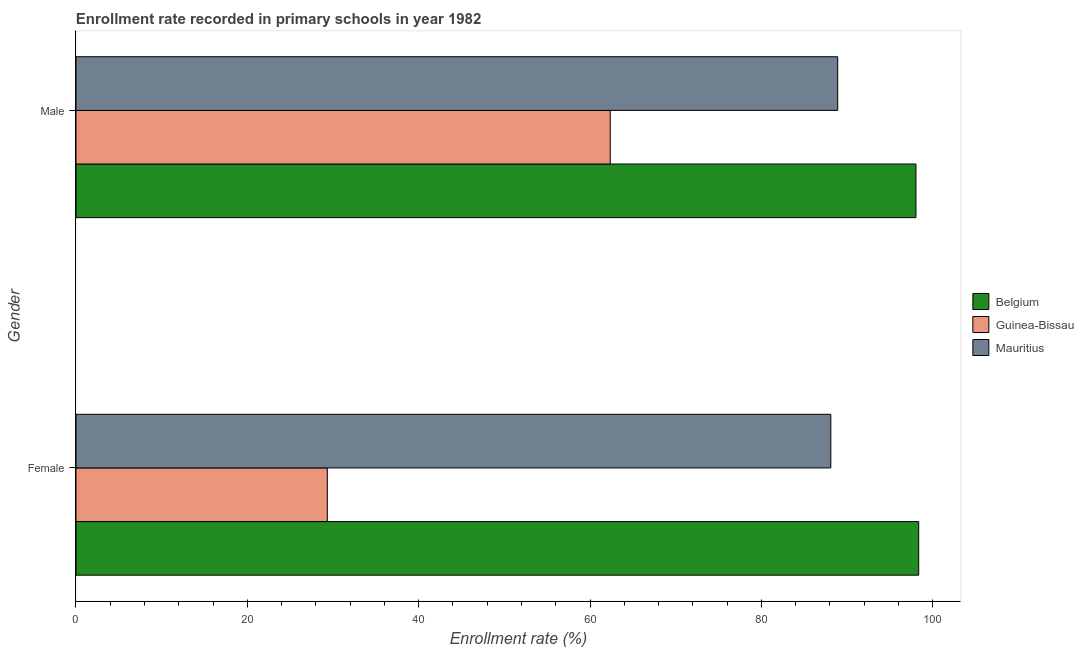Are the number of bars on each tick of the Y-axis equal?
Ensure brevity in your answer.  Yes. What is the label of the 2nd group of bars from the top?
Offer a very short reply. Female. What is the enrollment rate of male students in Belgium?
Your answer should be very brief. 98.04. Across all countries, what is the maximum enrollment rate of female students?
Offer a very short reply. 98.37. Across all countries, what is the minimum enrollment rate of female students?
Offer a terse response. 29.34. In which country was the enrollment rate of male students minimum?
Your answer should be very brief. Guinea-Bissau. What is the total enrollment rate of female students in the graph?
Provide a succinct answer. 215.81. What is the difference between the enrollment rate of male students in Guinea-Bissau and that in Mauritius?
Provide a succinct answer. -26.55. What is the difference between the enrollment rate of male students in Belgium and the enrollment rate of female students in Guinea-Bissau?
Keep it short and to the point. 68.71. What is the average enrollment rate of male students per country?
Ensure brevity in your answer.  83.1. What is the difference between the enrollment rate of female students and enrollment rate of male students in Mauritius?
Offer a very short reply. -0.8. In how many countries, is the enrollment rate of male students greater than 88 %?
Offer a terse response. 2. What is the ratio of the enrollment rate of female students in Belgium to that in Guinea-Bissau?
Offer a terse response. 3.35. Is the enrollment rate of female students in Mauritius less than that in Belgium?
Ensure brevity in your answer.  Yes. What does the 1st bar from the top in Male represents?
Your response must be concise. Mauritius. What does the 3rd bar from the bottom in Male represents?
Provide a succinct answer. Mauritius. Are the values on the major ticks of X-axis written in scientific E-notation?
Your answer should be very brief. No. Does the graph contain grids?
Make the answer very short. No. How many legend labels are there?
Your answer should be very brief. 3. What is the title of the graph?
Provide a succinct answer. Enrollment rate recorded in primary schools in year 1982. What is the label or title of the X-axis?
Offer a terse response. Enrollment rate (%). What is the Enrollment rate (%) in Belgium in Female?
Ensure brevity in your answer.  98.37. What is the Enrollment rate (%) of Guinea-Bissau in Female?
Ensure brevity in your answer.  29.34. What is the Enrollment rate (%) of Mauritius in Female?
Provide a short and direct response. 88.11. What is the Enrollment rate (%) of Belgium in Male?
Offer a very short reply. 98.04. What is the Enrollment rate (%) in Guinea-Bissau in Male?
Provide a short and direct response. 62.36. What is the Enrollment rate (%) of Mauritius in Male?
Your response must be concise. 88.91. Across all Gender, what is the maximum Enrollment rate (%) in Belgium?
Provide a short and direct response. 98.37. Across all Gender, what is the maximum Enrollment rate (%) in Guinea-Bissau?
Give a very brief answer. 62.36. Across all Gender, what is the maximum Enrollment rate (%) of Mauritius?
Provide a short and direct response. 88.91. Across all Gender, what is the minimum Enrollment rate (%) of Belgium?
Provide a short and direct response. 98.04. Across all Gender, what is the minimum Enrollment rate (%) of Guinea-Bissau?
Give a very brief answer. 29.34. Across all Gender, what is the minimum Enrollment rate (%) in Mauritius?
Provide a succinct answer. 88.11. What is the total Enrollment rate (%) of Belgium in the graph?
Provide a short and direct response. 196.41. What is the total Enrollment rate (%) of Guinea-Bissau in the graph?
Your answer should be very brief. 91.7. What is the total Enrollment rate (%) in Mauritius in the graph?
Your answer should be compact. 177.02. What is the difference between the Enrollment rate (%) in Belgium in Female and that in Male?
Your answer should be very brief. 0.32. What is the difference between the Enrollment rate (%) in Guinea-Bissau in Female and that in Male?
Your answer should be very brief. -33.03. What is the difference between the Enrollment rate (%) in Mauritius in Female and that in Male?
Provide a succinct answer. -0.8. What is the difference between the Enrollment rate (%) in Belgium in Female and the Enrollment rate (%) in Guinea-Bissau in Male?
Give a very brief answer. 36. What is the difference between the Enrollment rate (%) of Belgium in Female and the Enrollment rate (%) of Mauritius in Male?
Provide a succinct answer. 9.45. What is the difference between the Enrollment rate (%) of Guinea-Bissau in Female and the Enrollment rate (%) of Mauritius in Male?
Your response must be concise. -59.58. What is the average Enrollment rate (%) of Belgium per Gender?
Ensure brevity in your answer.  98.2. What is the average Enrollment rate (%) in Guinea-Bissau per Gender?
Make the answer very short. 45.85. What is the average Enrollment rate (%) in Mauritius per Gender?
Offer a very short reply. 88.51. What is the difference between the Enrollment rate (%) of Belgium and Enrollment rate (%) of Guinea-Bissau in Female?
Make the answer very short. 69.03. What is the difference between the Enrollment rate (%) in Belgium and Enrollment rate (%) in Mauritius in Female?
Provide a succinct answer. 10.26. What is the difference between the Enrollment rate (%) of Guinea-Bissau and Enrollment rate (%) of Mauritius in Female?
Ensure brevity in your answer.  -58.77. What is the difference between the Enrollment rate (%) in Belgium and Enrollment rate (%) in Guinea-Bissau in Male?
Provide a succinct answer. 35.68. What is the difference between the Enrollment rate (%) in Belgium and Enrollment rate (%) in Mauritius in Male?
Provide a short and direct response. 9.13. What is the difference between the Enrollment rate (%) of Guinea-Bissau and Enrollment rate (%) of Mauritius in Male?
Give a very brief answer. -26.55. What is the ratio of the Enrollment rate (%) in Guinea-Bissau in Female to that in Male?
Ensure brevity in your answer.  0.47. What is the ratio of the Enrollment rate (%) in Mauritius in Female to that in Male?
Your answer should be very brief. 0.99. What is the difference between the highest and the second highest Enrollment rate (%) of Belgium?
Ensure brevity in your answer.  0.32. What is the difference between the highest and the second highest Enrollment rate (%) of Guinea-Bissau?
Provide a succinct answer. 33.03. What is the difference between the highest and the second highest Enrollment rate (%) in Mauritius?
Your answer should be compact. 0.8. What is the difference between the highest and the lowest Enrollment rate (%) of Belgium?
Provide a short and direct response. 0.32. What is the difference between the highest and the lowest Enrollment rate (%) of Guinea-Bissau?
Keep it short and to the point. 33.03. What is the difference between the highest and the lowest Enrollment rate (%) of Mauritius?
Provide a succinct answer. 0.8. 